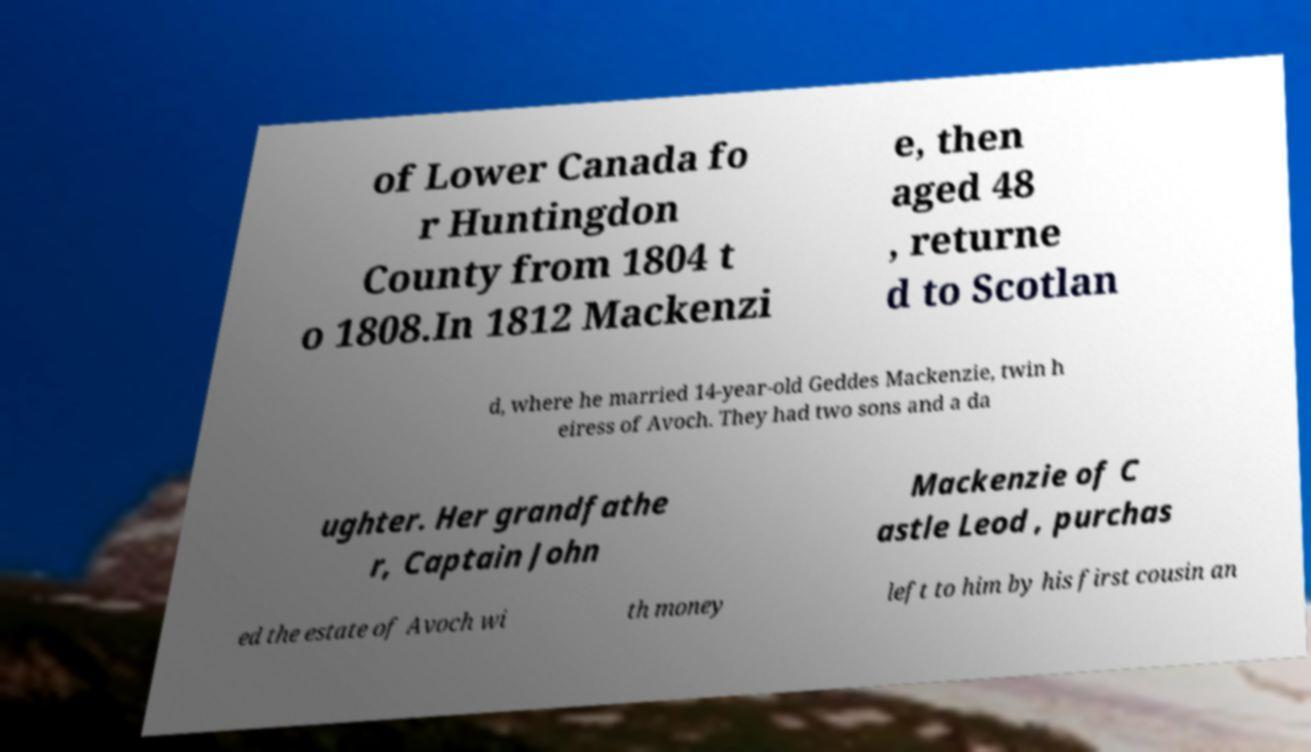Can you accurately transcribe the text from the provided image for me? of Lower Canada fo r Huntingdon County from 1804 t o 1808.In 1812 Mackenzi e, then aged 48 , returne d to Scotlan d, where he married 14-year-old Geddes Mackenzie, twin h eiress of Avoch. They had two sons and a da ughter. Her grandfathe r, Captain John Mackenzie of C astle Leod , purchas ed the estate of Avoch wi th money left to him by his first cousin an 